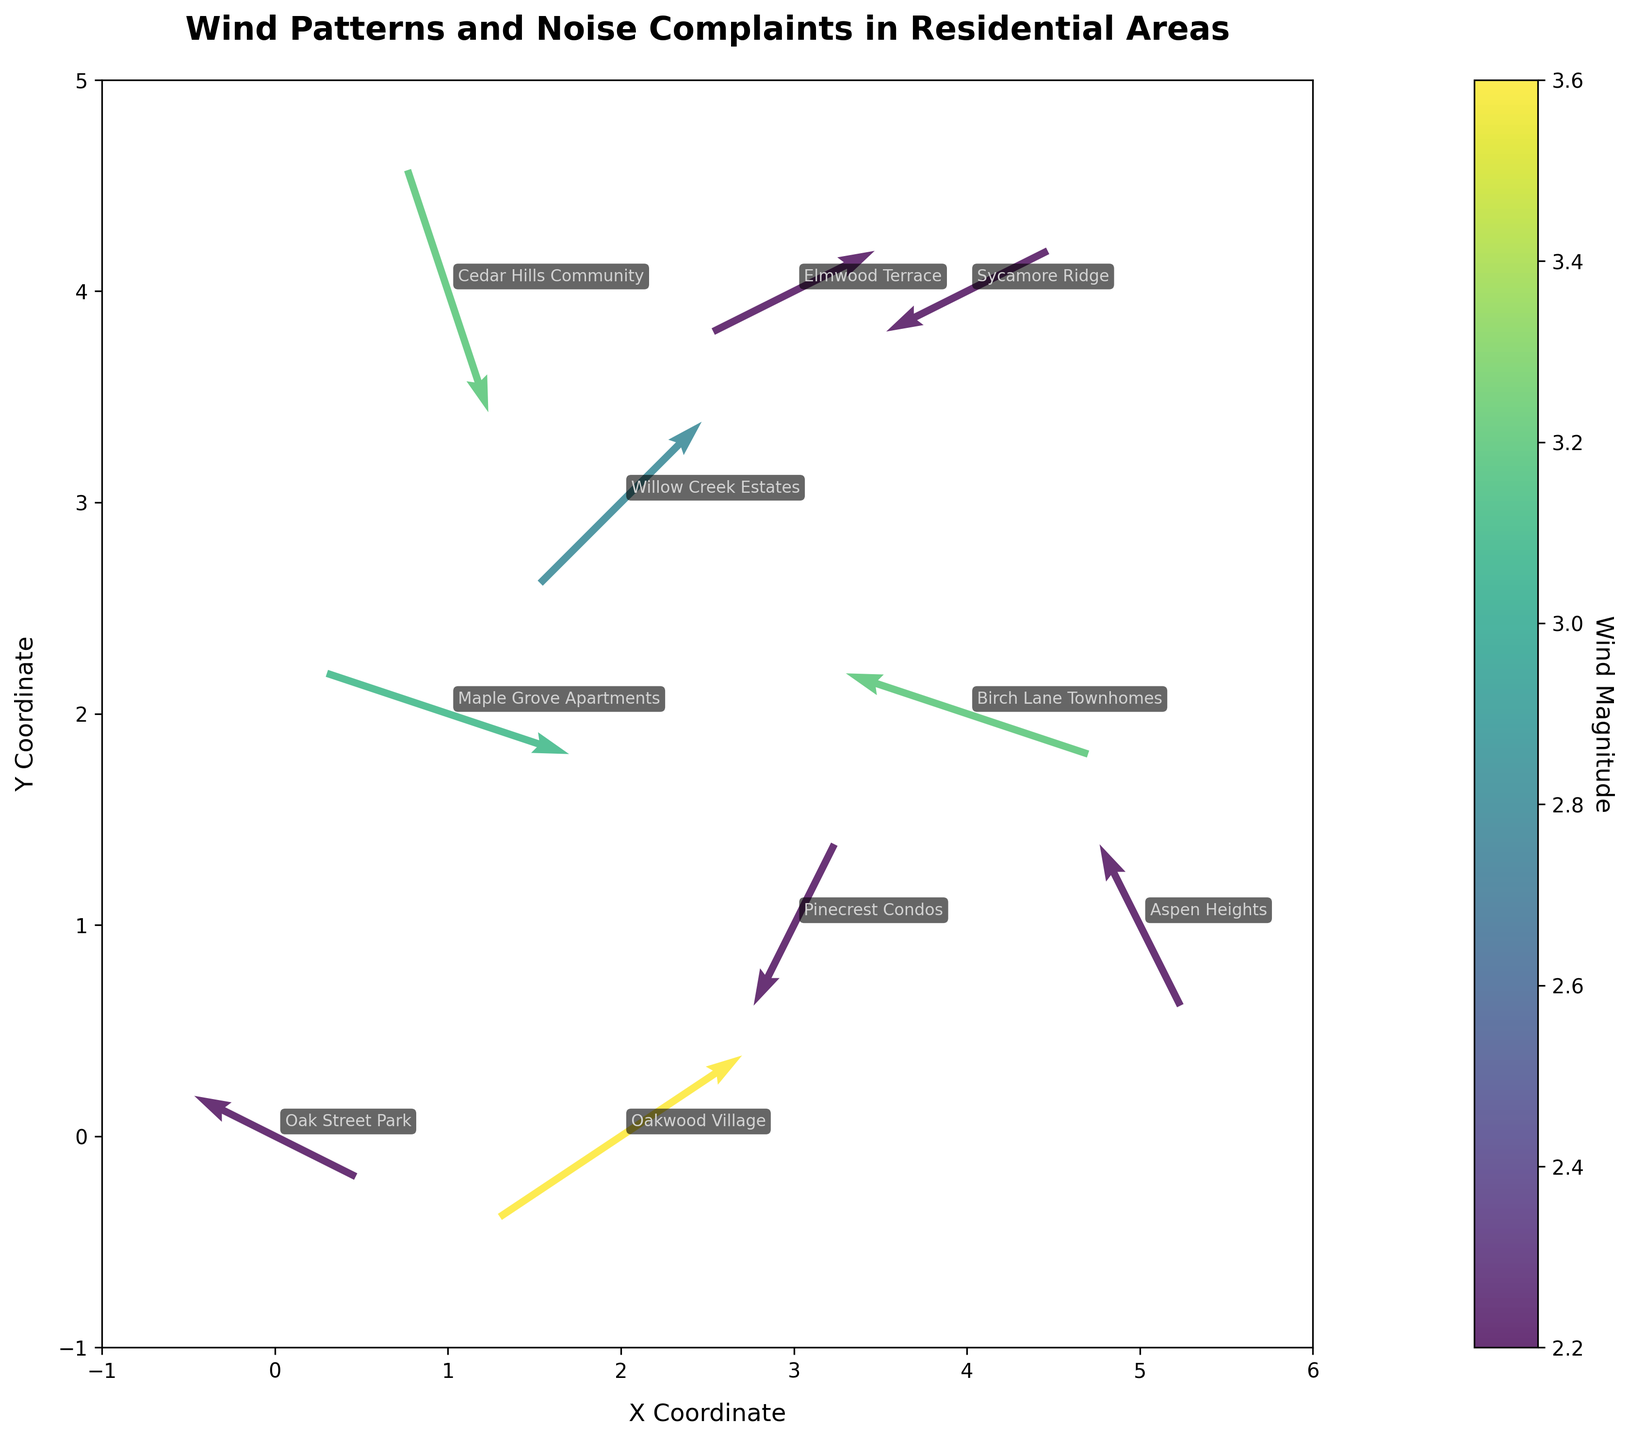What does the title of the figure tell us? The title of the figure is "Wind Patterns and Noise Complaints in Residential Areas", indicating that the plot shows the relationship between wind patterns (direction and magnitude) and noise complaints across different residential locations.
Answer: It shows wind patterns and noise complaints in residential areas What do the different arrow colors represent in the figure? The different arrow colors represent the wind magnitude, with a color gradient shown by the color bar on the right side of the plot.
Answer: Wind magnitude How many residential areas are displayed in the plot? There are 10 residential area labels in the plot, each corresponding to a different point.
Answer: 10 Which residential area is affected by the strongest wind magnitude? By referring to the color bar and the arrow colors, Oakwood Village has the darkest arrow, indicating the highest wind magnitude of 3.6.
Answer: Oakwood Village What are the X and Y coordinates for Willow Creek Estates? Willow Creek Estates is annotated at the coordinates (2, 3) in the figure.
Answer: (2, 3) Which two residential areas experience the same wind magnitude according to the figure? Pinecrest Condos and Oak Street Park both experience the same wind magnitude, indicated by the same color on the arrows and the value 2.2.
Answer: Pinecrest Condos and Oak Street Park What is the relationship between the wind direction at Cedar Hills Community and the one at Willow Creek Estates? Cedar Hills Community's arrow points downwards and to the left (south-west), while Willow Creek Estates' arrow points upwards and to the right (north-east), indicating opposite wind directions.
Answer: Opposite wind directions Across the plot, which direction does the majority of wind seem to come from? By observing the directions of the arrows across locations, the majority of the wind comes from the negative x-direction since many arrows point leftwards.
Answer: Negative x-direction Are there more areas experiencing wind with a magnitude below 3.0 or above 3.0? By counting the colors of the arrows that correlate with the magnitude values from the color bar, there are 6 areas with magnitudes below 3.0 and 4 areas with magnitudes above 3.0.
Answer: Below 3.0 Which residential area has an easterly wind component (positive x direction) and what is its y-direction value? By looking at the arrows, the residential areas with a positive x-direction component include: Maple Grove Apartments (3, -1), Willow Creek Estates (2, 2), Oakwood Village (3, 2). Their respective y-direction values are -1, 2, and 2.
Answer: Maple Grove Apartments, Willow Creek Estates, Oakwood Village 